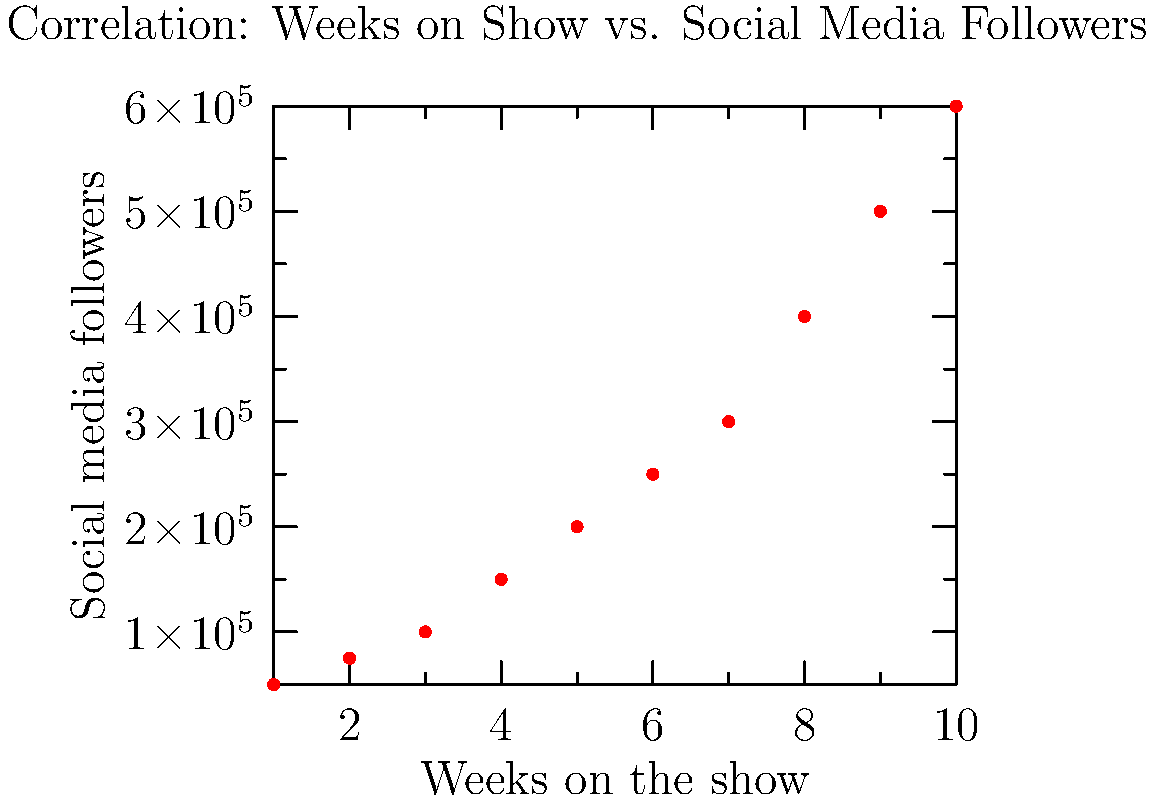Based on the scatter plot showing the relationship between a contestant's duration on The Bachelor and their social media following, what can be inferred about the correlation between these two variables? How might this trend impact future casting decisions and contestant strategies? To analyze the correlation between weeks on the show and social media followers:

1. Observe the overall trend: The scatter plot shows a clear positive relationship between the two variables.

2. Strength of correlation: The points form a relatively straight line, indicating a strong positive correlation.

3. Interpretation: As contestants stay longer on the show, their social media following tends to increase.

4. Quantitative assessment: We can estimate that for each additional week on the show, a contestant gains roughly 50,000-75,000 followers.

5. Outliers: There don't appear to be significant outliers, suggesting a consistent trend across contestants.

6. Impact on casting: Producers might favor contestants with higher initial social media followings, anticipating greater audience engagement.

7. Contestant strategies: Participants may focus on longevity in the show to boost their social media presence, potentially impacting their behavior and decisions during filming.

8. Long-term effects: Contestants staying until the final weeks (8-10) see a dramatic increase in followers, potentially leading to influencer careers post-show.

9. Mutual benefit: The show benefits from contestants with growing followings through increased engagement and cross-promotion.

10. Ethical considerations: This trend might influence authentic relationship-building on the show, as contestants may prioritize screen time over genuine connections.
Answer: Strong positive correlation; longer duration on show significantly increases social media following, likely influencing casting and contestant behavior. 